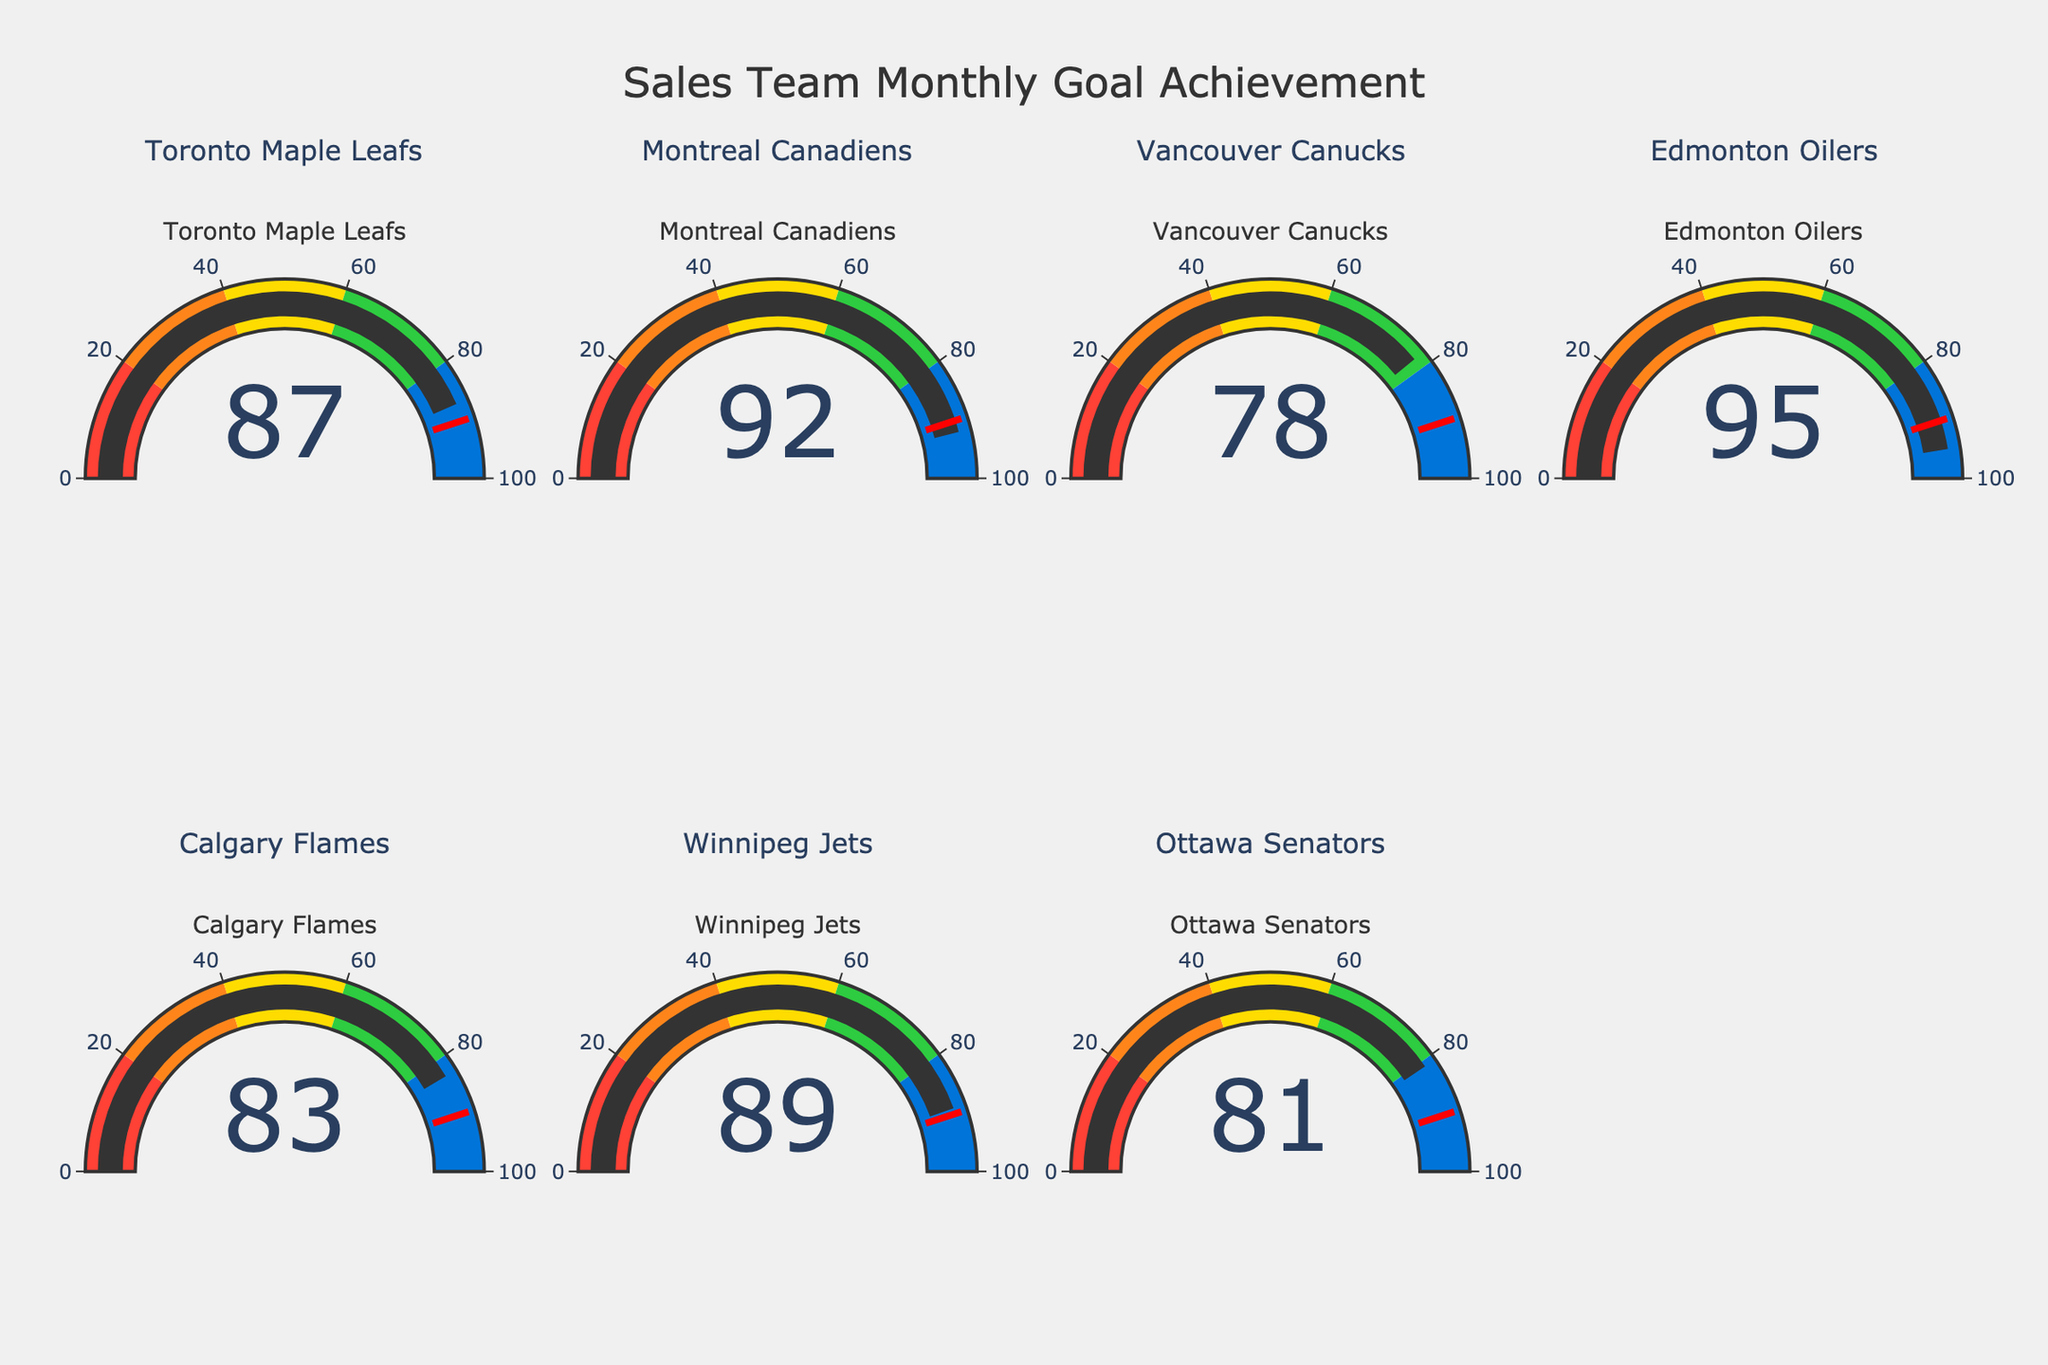Which team has the highest goal achievement percentage? Look at all the gauge charts and identify the one with the highest percentage value. Edmonton Oilers has a value of 95, which is the highest.
Answer: Edmonton Oilers How many teams achieved more than 90% of their goals? Check the percentage values on each gauge chart. Count the teams with values above 90%. There are two teams: Montreal Canadiens (92) and Edmonton Oilers (95).
Answer: 2 What's the average goal achievement percentage for all teams? Sum the values of all teams: 87 + 92 + 78 + 95 + 83 + 89 + 81 = 605. Divide by the number of teams: 605 / 7 ≈ 86.43.
Answer: 86.43 Which team has the lowest goal achievement percentage? Examine all gauge charts and find the team with the smallest percentage value. Vancouver Canucks has the lowest value of 78.
Answer: Vancouver Canucks Compare the goal achievement percentages of Toronto Maple Leafs and Ottawa Senators. Which team did better? Toronto Maple Leafs has a value of 87, and Ottawa Senators has a value of 81. Toronto Maple Leafs did better.
Answer: Toronto Maple Leafs Is the goal achievement percentage of the Calgary Flames greater than the average percentage of all teams? Calculate the average (86.43) and compare it to Calgary Flames's percentage (83). Calgary Flames has a lower percentage.
Answer: No How many teams achieved less than 85% of their goals? Check the values on each gauge chart and count the teams with percentages below 85%. There are three teams: Vancouver Canucks (78), Calgary Flames (83), and Ottawa Senators (81).
Answer: 3 Which team exceeded the 90% achievement threshold and by how much? Identify teams with values above 90%. Edmonton Oilers (95) exceeded by 5, and Montreal Canadiens (92) exceeded by 2.
Answer: Edmonton Oilers by 5, Montreal Canadiens by 2 What's the difference between the highest and lowest goal achievement percentages? Identify the highest percentage (Edmonton Oilers, 95) and the lowest (Vancouver Canucks, 78). Calculate the difference: 95 - 78 = 17.
Answer: 17 Is any team's achievement percentage exactly on the 90% threshold? Check if any gauge chart shows an exact value of 90%. No team shows exactly 90%.
Answer: No 